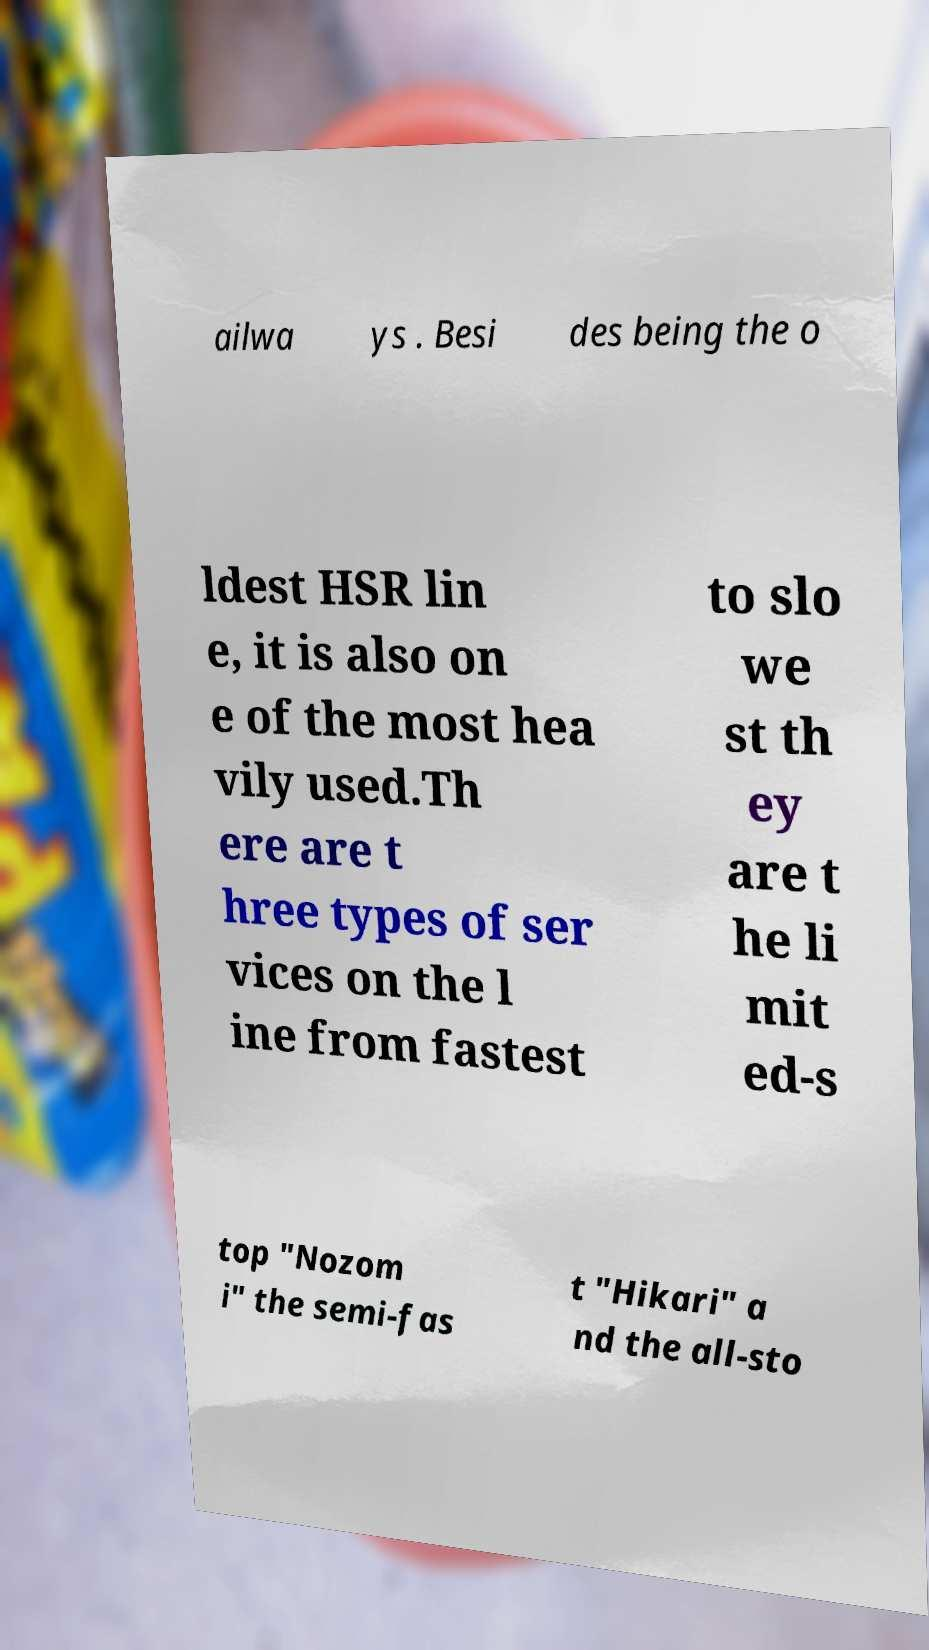I need the written content from this picture converted into text. Can you do that? ailwa ys . Besi des being the o ldest HSR lin e, it is also on e of the most hea vily used.Th ere are t hree types of ser vices on the l ine from fastest to slo we st th ey are t he li mit ed-s top "Nozom i" the semi-fas t "Hikari" a nd the all-sto 